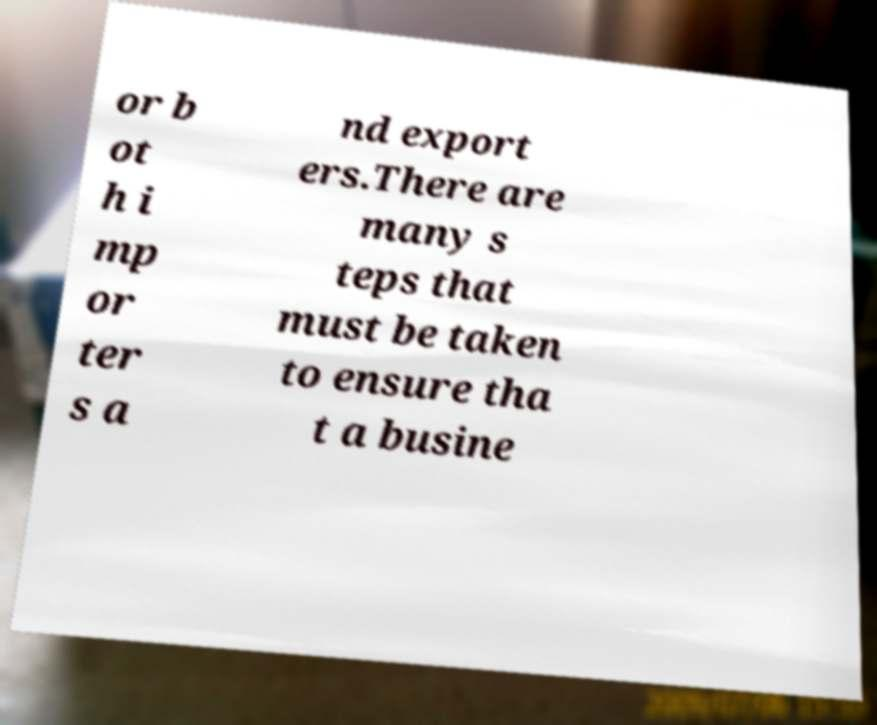There's text embedded in this image that I need extracted. Can you transcribe it verbatim? or b ot h i mp or ter s a nd export ers.There are many s teps that must be taken to ensure tha t a busine 